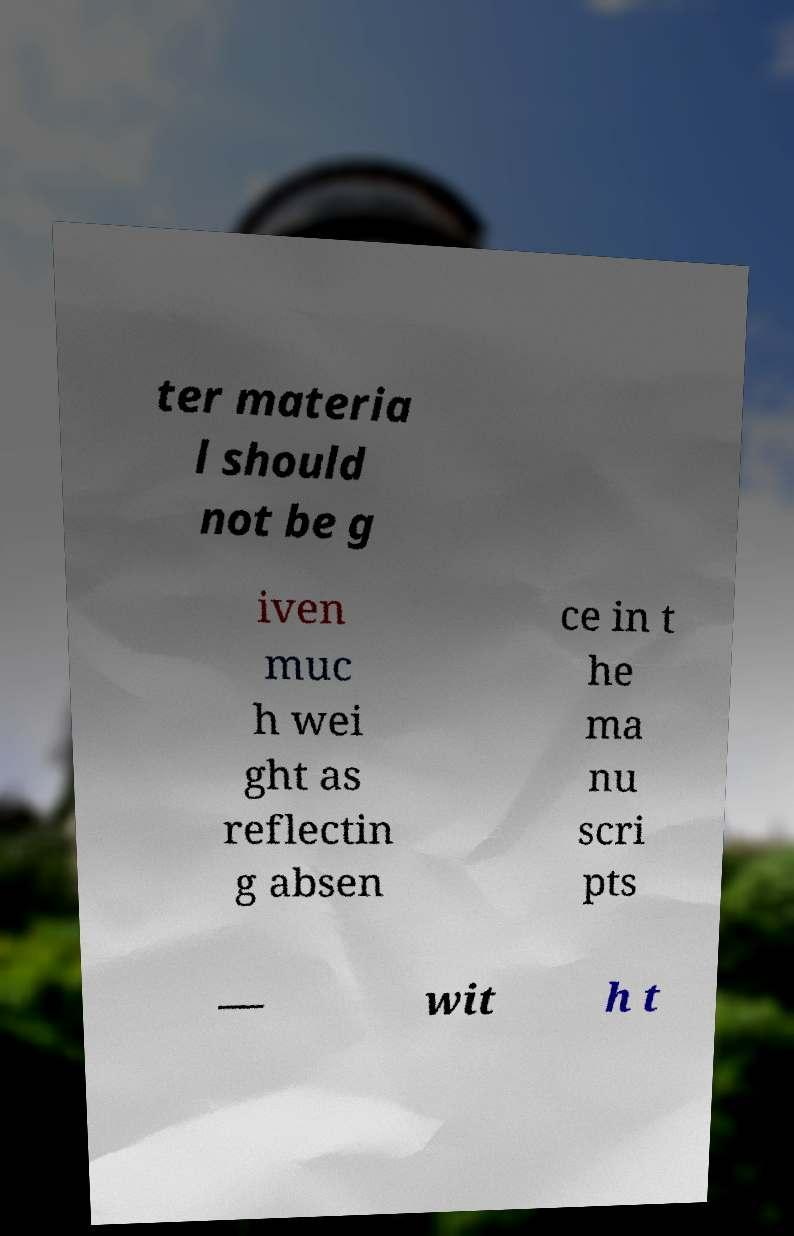Please read and relay the text visible in this image. What does it say? ter materia l should not be g iven muc h wei ght as reflectin g absen ce in t he ma nu scri pts — wit h t 